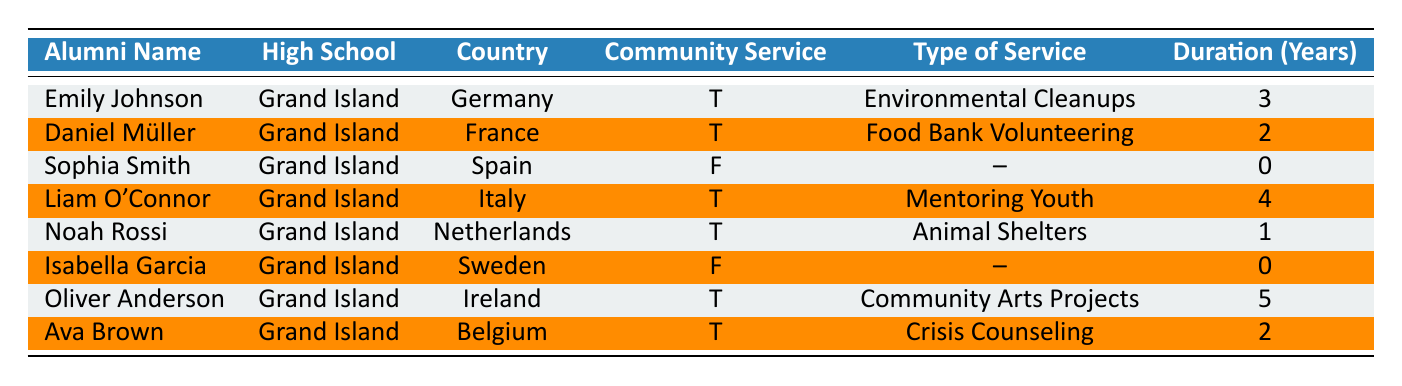What are the names of alumni involved in community service in Italy? Liam O'Connor is the only alumnus listed who is involved in community service in Italy, as indicated in the table.
Answer: Liam O'Connor How many years has Oliver Anderson been involved in community service? The table shows that Oliver Anderson has been involved in community service for 5 years.
Answer: 5 years Is there any alumnus from France who is not involved in community service? The table indicates that Daniel Müller, an alumnus from France, is involved in community service. Therefore, there is no alumnus from France who is not involved.
Answer: No What type of community service does Noah Rossi engage in? According to the table, Noah Rossi engages in community service for Animal Shelters.
Answer: Animal Shelters What is the average duration of community service among those who are involved? The involved alumni are Emily Johnson (3 years), Daniel Müller (2 years), Liam O'Connor (4 years), Noah Rossi (1 year), Oliver Anderson (5 years), and Ava Brown (2 years). Summing these gives 3 + 2 + 4 + 1 + 5 + 2 = 17 years. There are 6 involved alumni, so the average duration is 17/6, which is approximately 2.83 years.
Answer: 2.83 years How many alumni from the table have not participated in community service? The table shows Sophia Smith and Isabella Garcia as alumni who are not involved in community service. Thus, there are 2 alumni who have not participated.
Answer: 2 Which country has the alumnus with the highest duration of community service? Oliver Anderson, from Ireland, has the highest duration of community service, which is 5 years. This can be confirmed by comparing the durations in the table.
Answer: Ireland What type of service has Ava Brown provided? The table clearly indicates that Ava Brown has provided Crisis Counseling as her type of community service involvement.
Answer: Crisis Counseling 